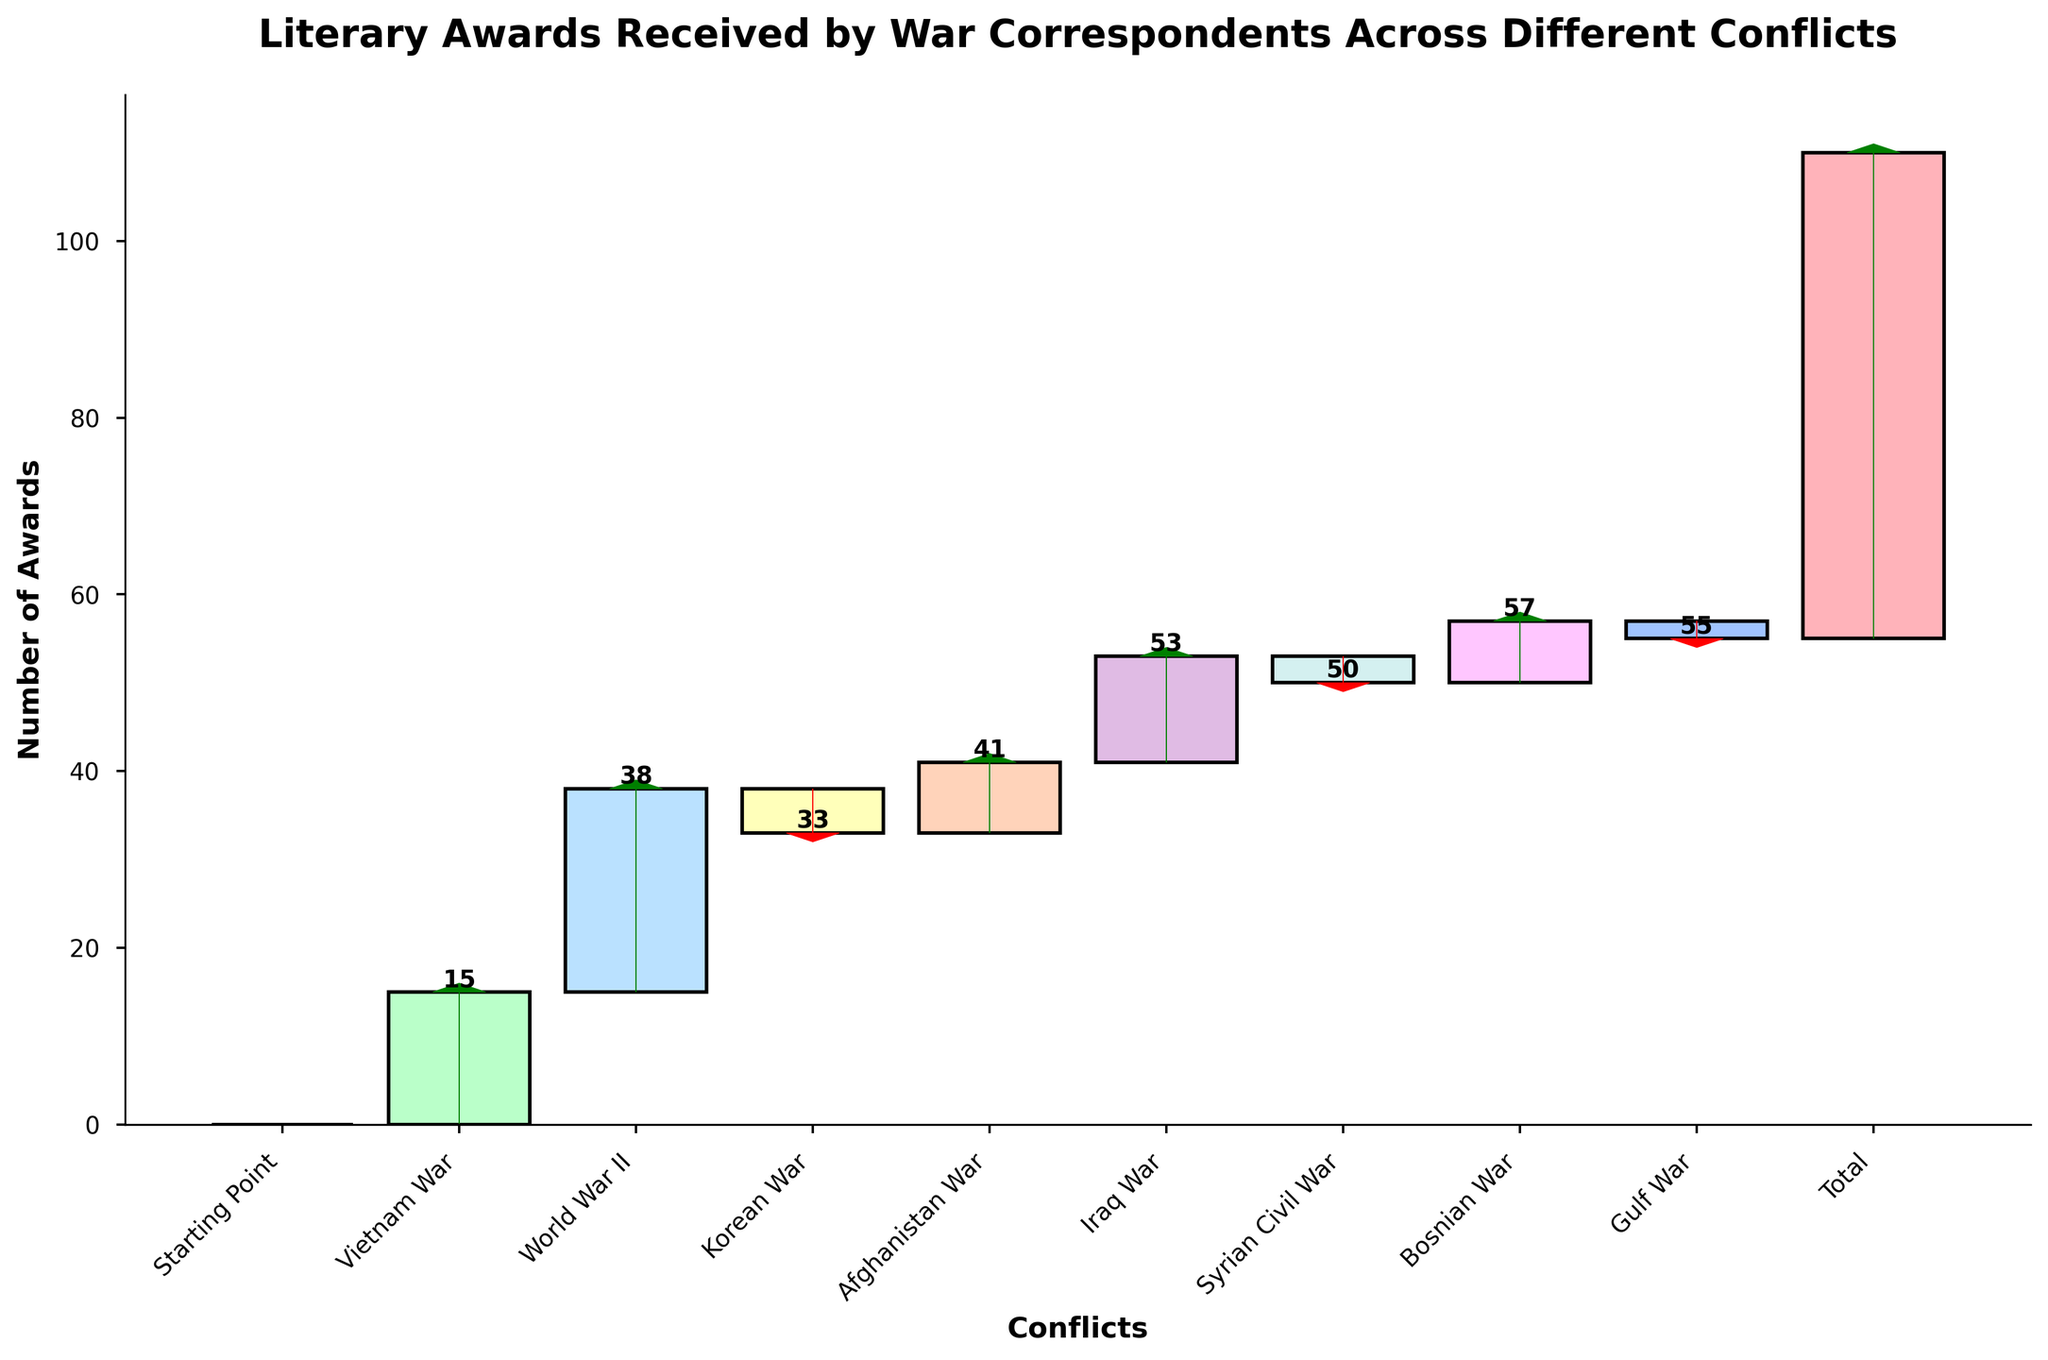How many conflicts are represented in the chart? Counting the unique conflicts listed on the x-axis of the chart gives the number of conflicts represented. These are Vietnam War, World War II, Korean War, Afghanistan War, Iraq War, Syrian Civil War, Bosnian War, and Gulf War.
Answer: 8 What is the maximum increase in awards for a specific conflict? Comparing the increases shown by the bars, the maximum increase is for World War II, which is 23 awards.
Answer: 23 Which conflict contributed the highest negative change in the number of awards? By comparing the negative sections of the bars, the Korean War shows the highest negative change with -5 awards.
Answer: Korean War What is the cumulative number of awards after the Iraq War is included? Adding the cumulative numbers up to and including the Iraq War, we get: 0 (Starting Point) + 15 (Vietnam War) + 23 (World War II) - 5 (Korean War) + 8 (Afghanistan War) + 12 (Iraq War) = 53.
Answer: 53 What colors are used to represent the conflicts in the chart? Looking at the bars, the chart uses a variety of pastel colors including shades of pink, green, blue, yellow, orange, purple, teal, and light blue.
Answer: Pastel colors What is the average number of awards per conflict? Adding the values of all the conflicts and dividing by the number of conflicts: (15 + 23 - 5 + 8 + 12 - 3 + 7 - 2) / 8 = 55/8 = 6.875.
Answer: 6.88 How many positive changes in awards are there? Counting the positive changes (bars above the axis), we find they are: Vietnam War, World War II, Afghanistan War, Iraq War, Bosnian War. There are 5 of them.
Answer: 5 Which conflicts show a decrease in the number of awards? Observing the negative sections of the bars, the conflicts are Korean War, Syrian Civil War, and Gulf War.
Answer: 3 